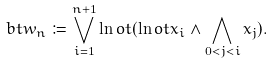Convert formula to latex. <formula><loc_0><loc_0><loc_500><loc_500>b t w _ { n } \coloneqq \bigvee _ { i = 1 } ^ { n + 1 } \ln o t ( \ln o t x _ { i } \land \bigwedge _ { 0 < j < i } x _ { j } ) .</formula> 